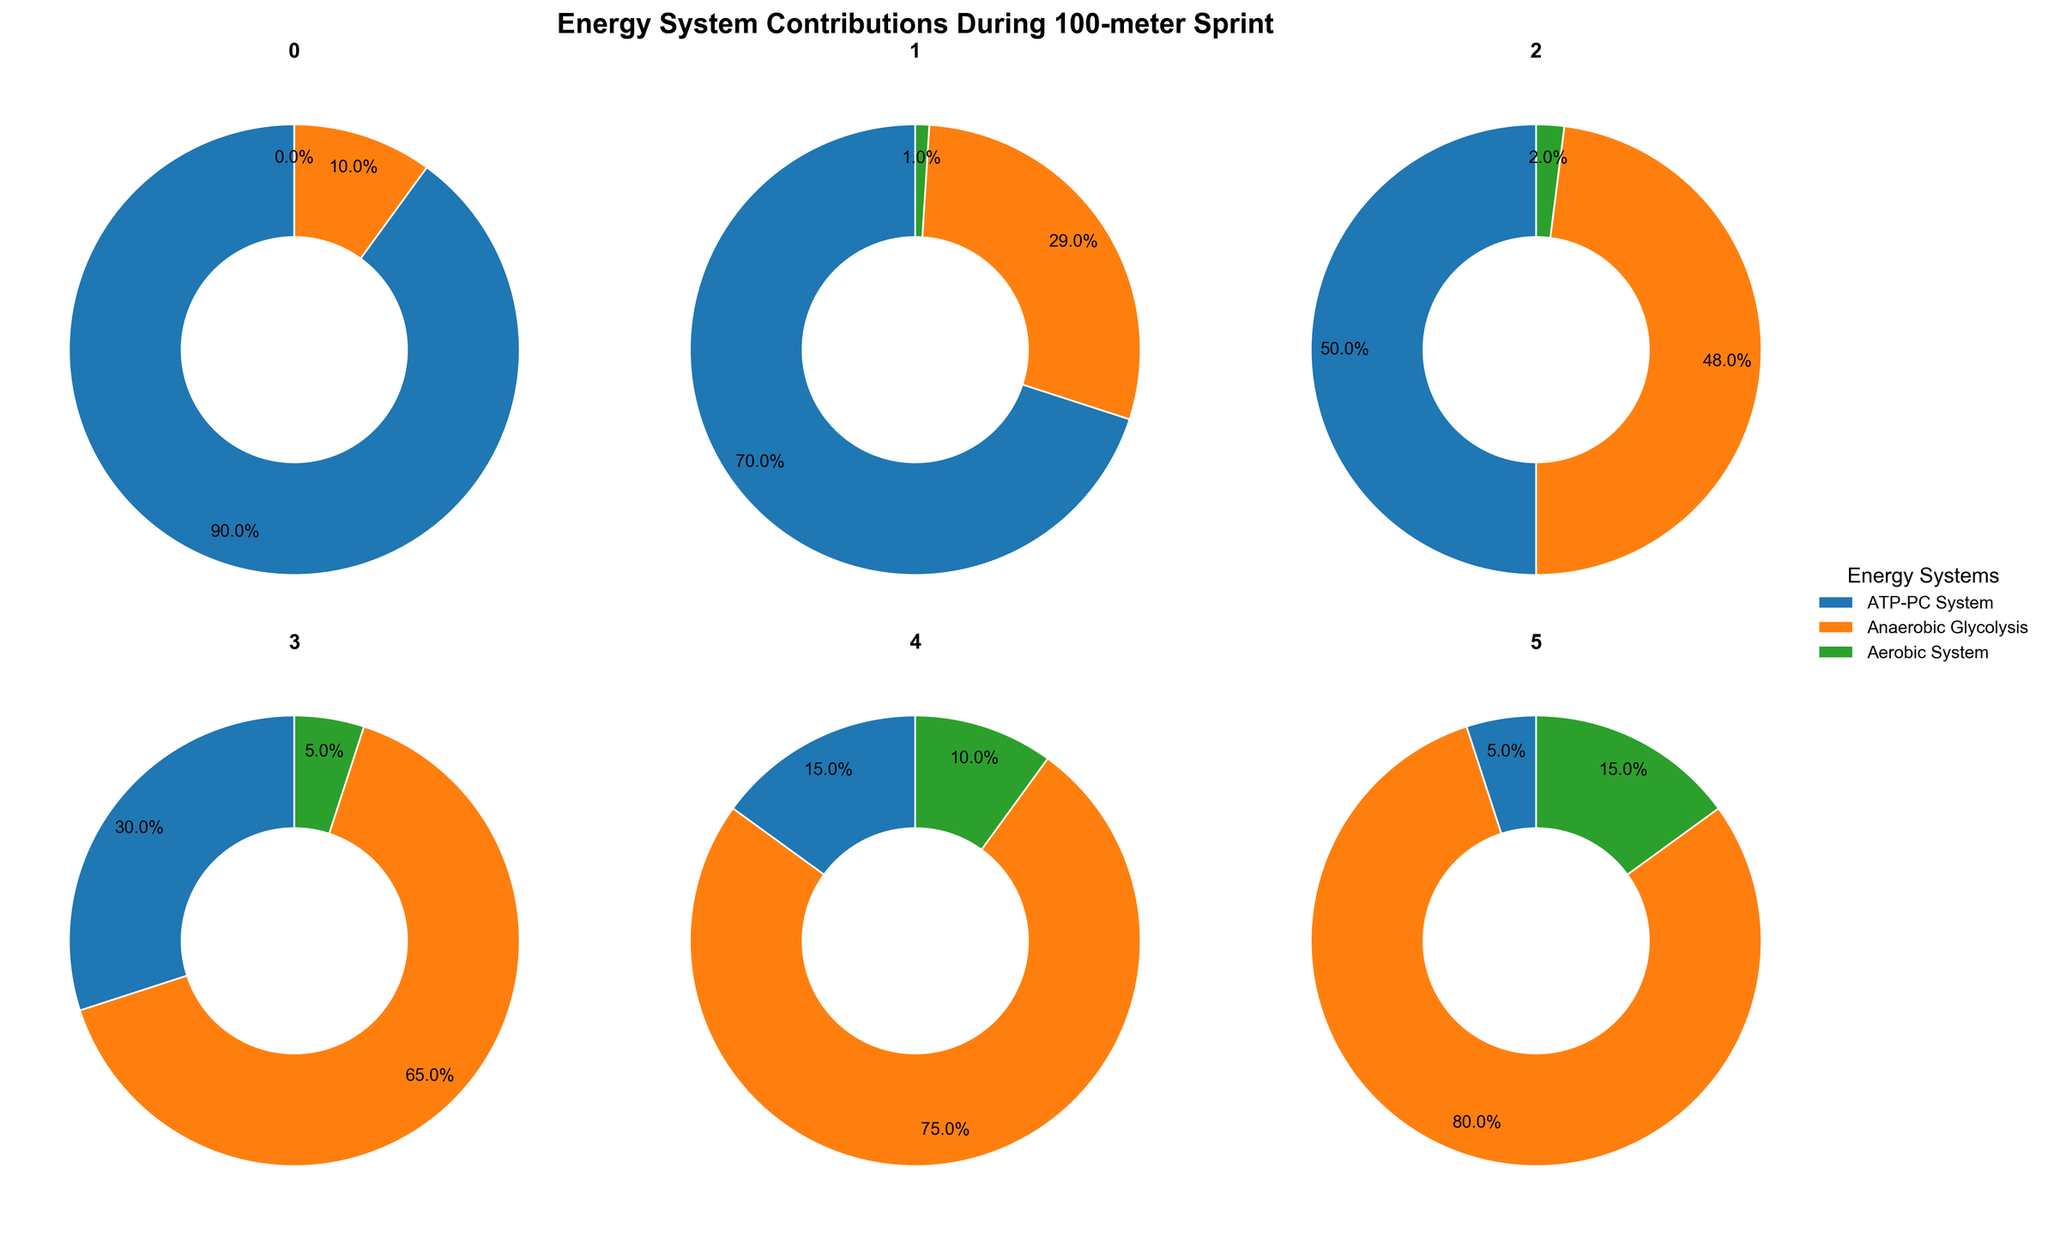What's the title of the figure? The title is written at the top of the figure. It reads "Energy System Contributions During 100-meter Sprint".
Answer: Energy System Contributions During 100-meter Sprint Which energy system has the highest contribution in the 0-10 seconds duration? Look at the pie chart titled "0-10 seconds" and identify the largest pie slice. The ATP-PC System has the highest contribution.
Answer: ATP-PC System How much percentage does the Aerobic System contribute in the 40-50 seconds duration? Look at the pie chart for the "40-50 seconds" duration. The Aerobic System contributes 10% according to the pie slice label.
Answer: 10% What is the most significant change in the Anaerobic Glycolysis contribution between two consecutive time slots? Compare the percentages of Anaerobic Glycolysis in each consecutive time slot. The largest change occurs between 30-40 seconds (65%) and 40-50 seconds (75%), with a difference of 10%.
Answer: 10% Which time duration sees the least contribution from the ATP-PC System? Examine all the pie charts and identify the smallest ATP-PC System slice. The "50-60 seconds" duration shows the least contribution from the ATP-PC System at 5%.
Answer: 50-60 seconds How does the contribution of the Aerobic System change from 0-10 seconds to 50-60 seconds? Identify the Aerobic System contributions in both time slots: 0% in 0-10 seconds and 15% in 50-60 seconds. The change is an increase from 0% to 15%.
Answer: Increases from 0% to 15% Which energy system shows a consistent increase across all time durations? Analyze each pie chart to see which system's contribution is increasing in each subsequent duration. The Aerobic System consistently increases from 0% (0-10 seconds) to 15% (50-60 seconds).
Answer: Aerobic System What is the combined contribution of the ATP-PC System and Anaerobic Glycolysis in the 10-20 seconds duration? Add the contributions of the ATP-PC System (70%) and Anaerobic Glycolysis (29%) in the 10-20 seconds duration. Their combined contribution is 99%.
Answer: 99% Is there any time duration where the contribution of the Aerobic System is higher than the ATP-PC System? Compare the percentages of Aerobic and ATP-PC Systems across all time slots. In the 50-60 seconds duration, the Aerobic System (15%) is higher than the ATP-PC System (5%).
Answer: Yes, in 50-60 seconds Which energy system has the greatest overall reduction in its contribution from the first to the last time duration? Compare the contributions of each system in the first (0-10 seconds) and last (50-60 seconds) time durations. The ATP-PC System decreases from 90% to 5%, a reduction of 85%.
Answer: ATP-PC System 